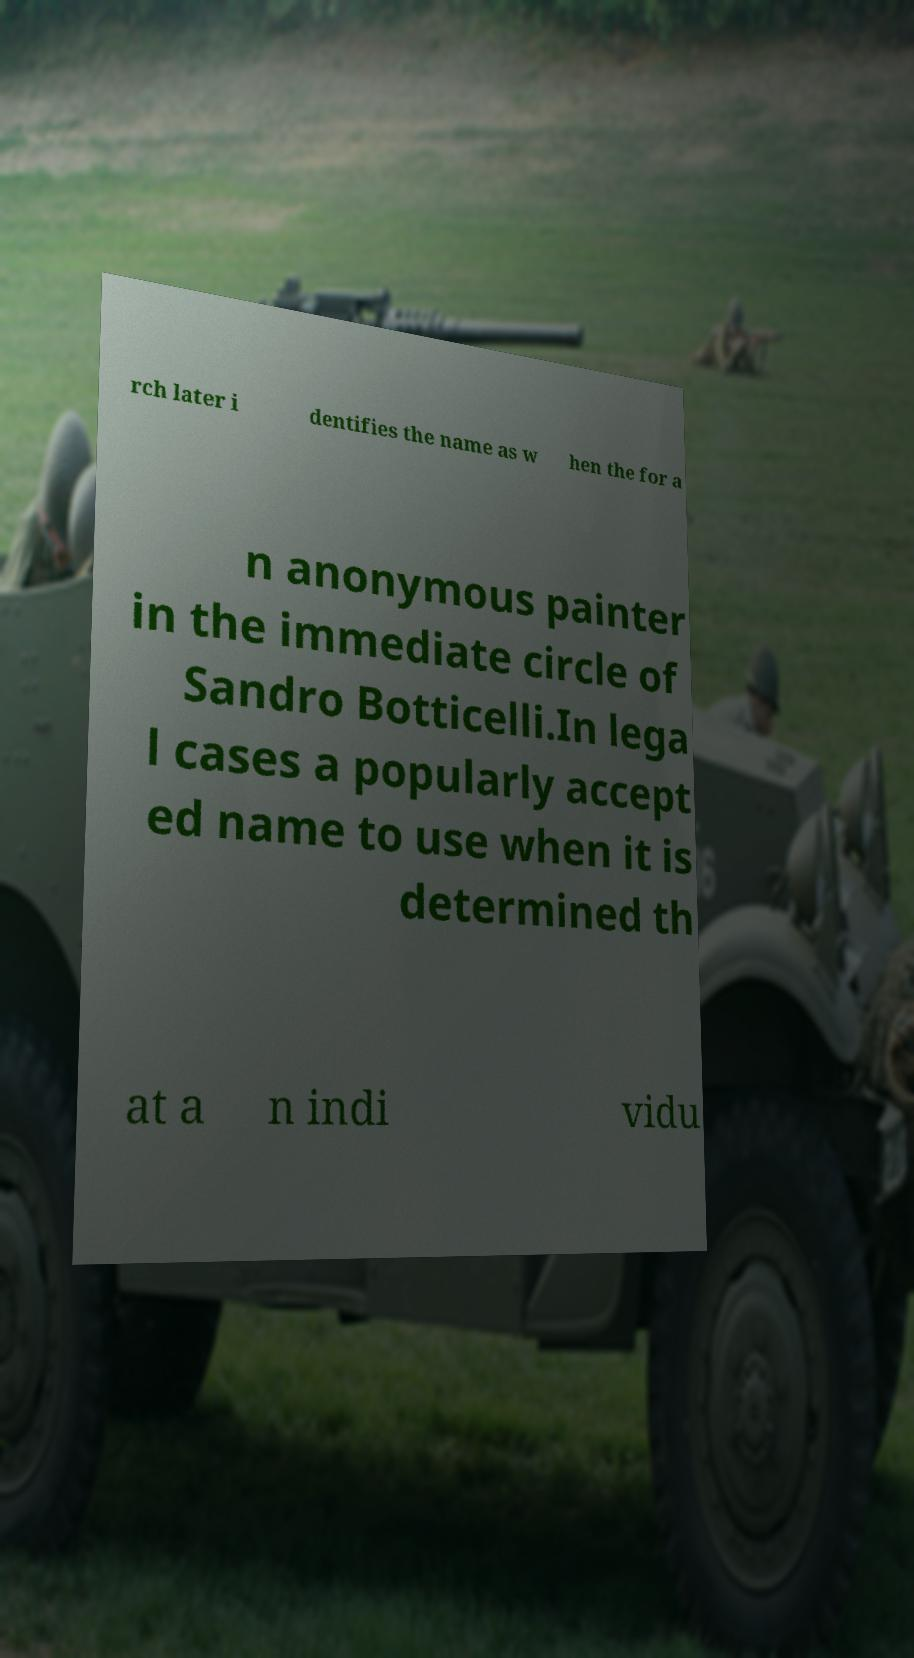Can you accurately transcribe the text from the provided image for me? rch later i dentifies the name as w hen the for a n anonymous painter in the immediate circle of Sandro Botticelli.In lega l cases a popularly accept ed name to use when it is determined th at a n indi vidu 